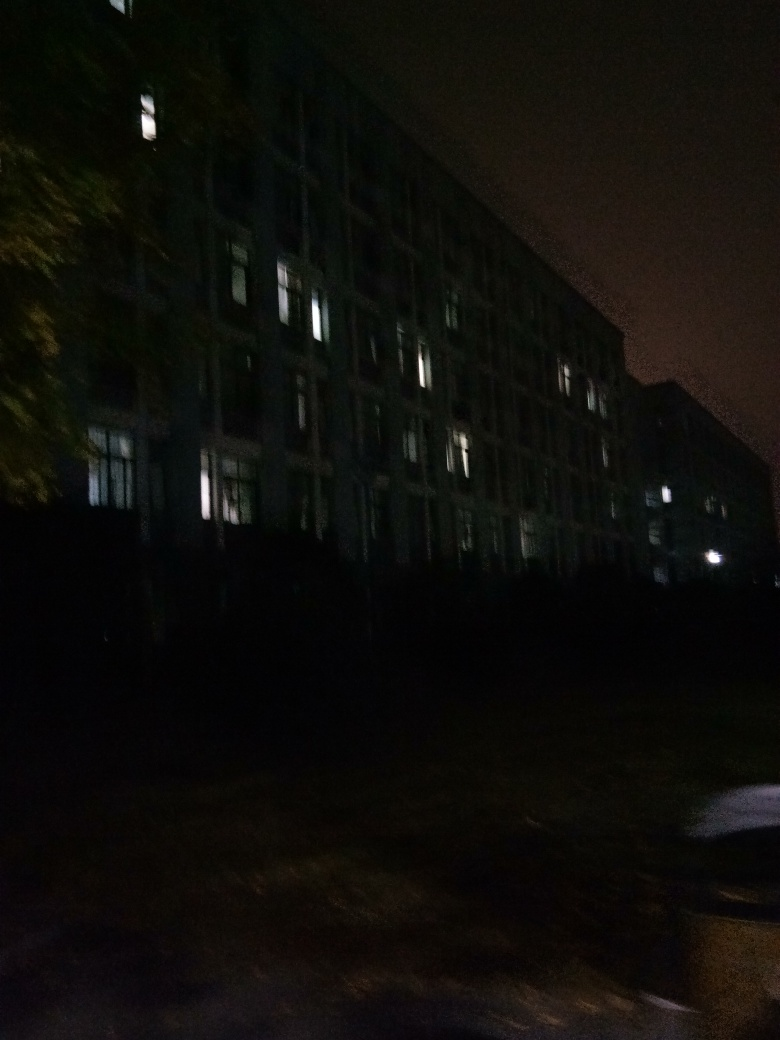What kind of effect is present in this photo? Based on the analysis of the photo, it appears there is a slight ghosting effect caused by a slow shutter speed or motion. This effect creates a blur or double image which adds an ethereal or haunting quality to the scene. It's most noticeable on illuminated objects, like the windows, against the darker background. 